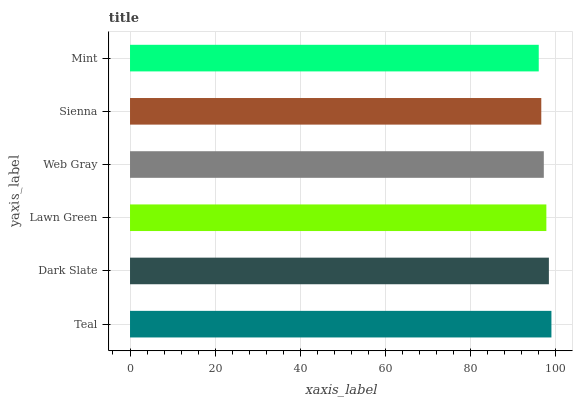Is Mint the minimum?
Answer yes or no. Yes. Is Teal the maximum?
Answer yes or no. Yes. Is Dark Slate the minimum?
Answer yes or no. No. Is Dark Slate the maximum?
Answer yes or no. No. Is Teal greater than Dark Slate?
Answer yes or no. Yes. Is Dark Slate less than Teal?
Answer yes or no. Yes. Is Dark Slate greater than Teal?
Answer yes or no. No. Is Teal less than Dark Slate?
Answer yes or no. No. Is Lawn Green the high median?
Answer yes or no. Yes. Is Web Gray the low median?
Answer yes or no. Yes. Is Sienna the high median?
Answer yes or no. No. Is Lawn Green the low median?
Answer yes or no. No. 